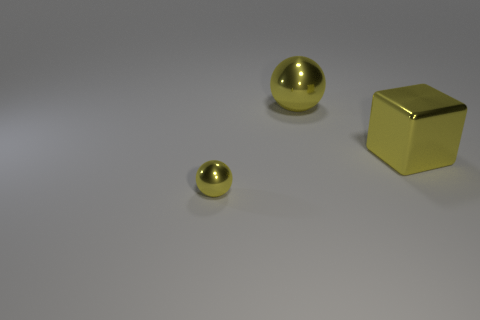Add 2 tiny yellow objects. How many objects exist? 5 Subtract all blocks. How many objects are left? 2 Add 1 metallic things. How many metallic things exist? 4 Subtract 0 cyan cylinders. How many objects are left? 3 Subtract all tiny yellow matte spheres. Subtract all shiny cubes. How many objects are left? 2 Add 2 big yellow cubes. How many big yellow cubes are left? 3 